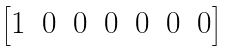<formula> <loc_0><loc_0><loc_500><loc_500>\begin{bmatrix} 1 & 0 & 0 & 0 & 0 & 0 & 0 \end{bmatrix}</formula> 